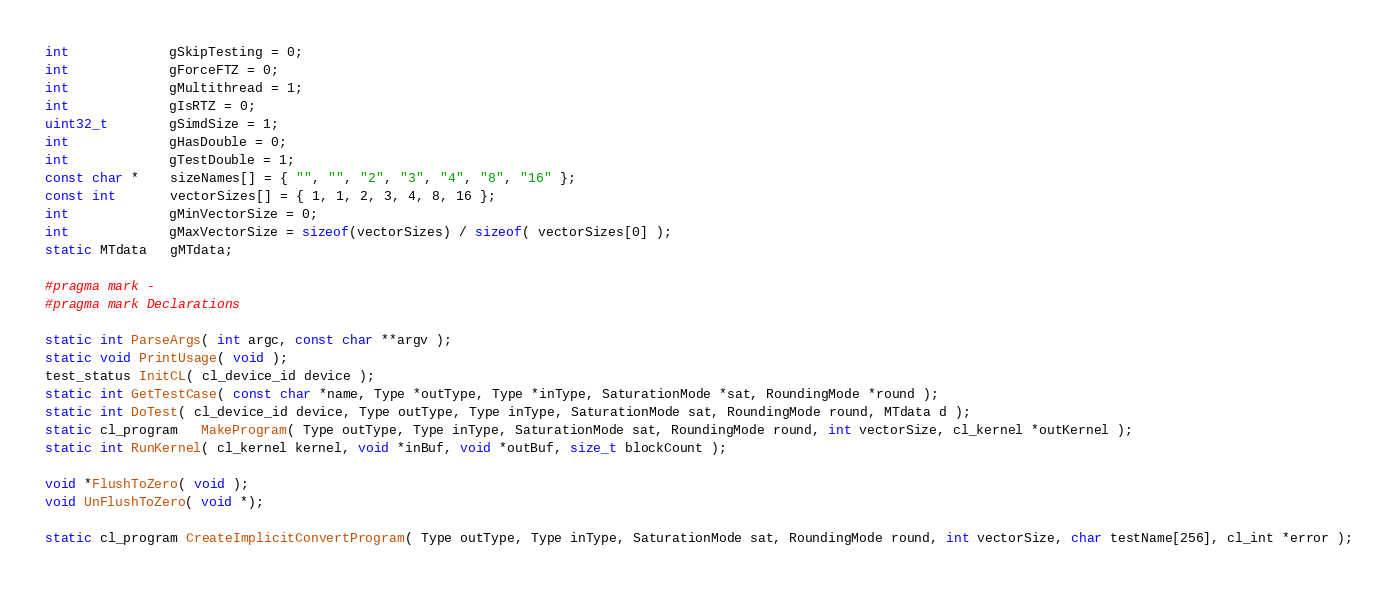Convert code to text. <code><loc_0><loc_0><loc_500><loc_500><_C++_>int             gSkipTesting = 0;
int             gForceFTZ = 0;
int             gMultithread = 1;
int             gIsRTZ = 0;
uint32_t        gSimdSize = 1;
int             gHasDouble = 0;
int             gTestDouble = 1;
const char *    sizeNames[] = { "", "", "2", "3", "4", "8", "16" };
const int       vectorSizes[] = { 1, 1, 2, 3, 4, 8, 16 };
int             gMinVectorSize = 0;
int             gMaxVectorSize = sizeof(vectorSizes) / sizeof( vectorSizes[0] );
static MTdata   gMTdata;

#pragma mark -
#pragma mark Declarations

static int ParseArgs( int argc, const char **argv );
static void PrintUsage( void );
test_status InitCL( cl_device_id device );
static int GetTestCase( const char *name, Type *outType, Type *inType, SaturationMode *sat, RoundingMode *round );
static int DoTest( cl_device_id device, Type outType, Type inType, SaturationMode sat, RoundingMode round, MTdata d );
static cl_program   MakeProgram( Type outType, Type inType, SaturationMode sat, RoundingMode round, int vectorSize, cl_kernel *outKernel );
static int RunKernel( cl_kernel kernel, void *inBuf, void *outBuf, size_t blockCount );

void *FlushToZero( void );
void UnFlushToZero( void *);

static cl_program CreateImplicitConvertProgram( Type outType, Type inType, SaturationMode sat, RoundingMode round, int vectorSize, char testName[256], cl_int *error );</code> 